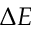<formula> <loc_0><loc_0><loc_500><loc_500>\Delta E</formula> 